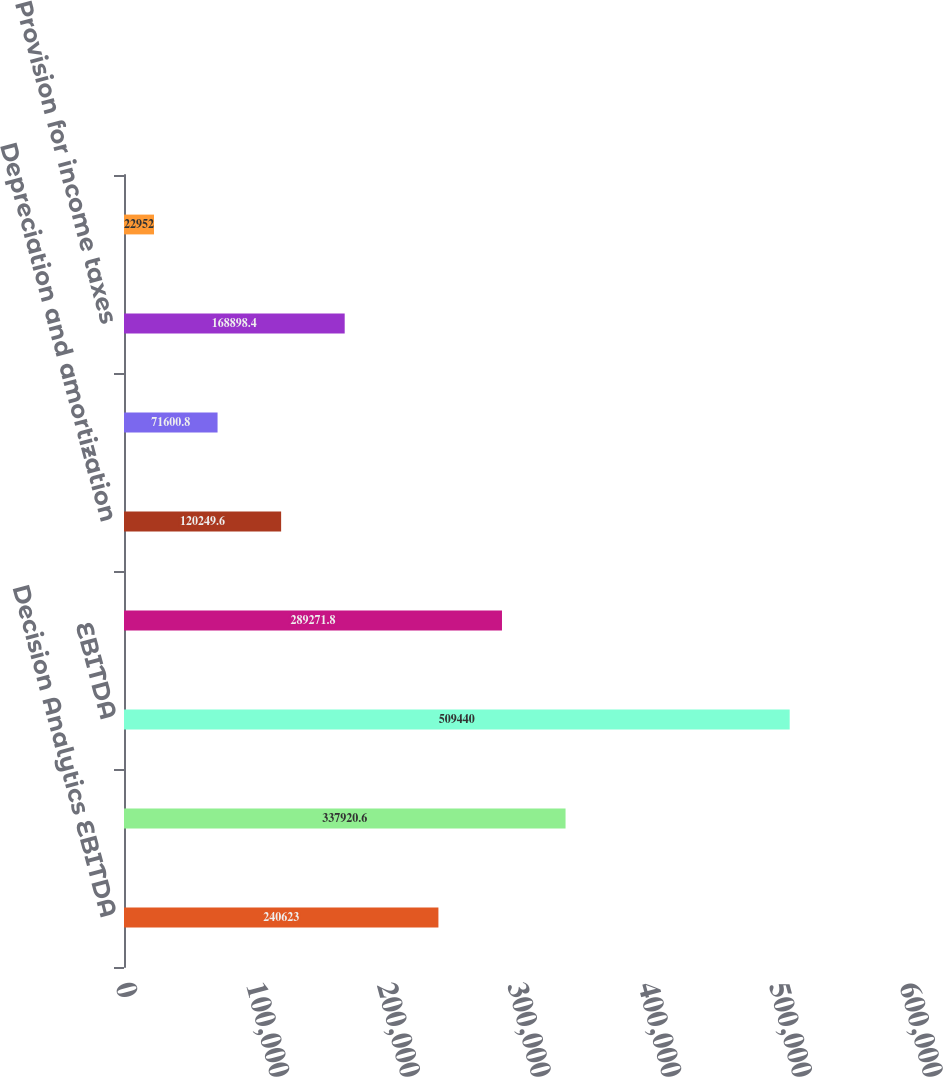Convert chart to OTSL. <chart><loc_0><loc_0><loc_500><loc_500><bar_chart><fcel>Decision Analytics EBITDA<fcel>Risk Assessment EBITDA<fcel>EBITDA<fcel>Net income<fcel>Depreciation and amortization<fcel>Interest expense from<fcel>Provision for income taxes<fcel>Depreciation amortization<nl><fcel>240623<fcel>337921<fcel>509440<fcel>289272<fcel>120250<fcel>71600.8<fcel>168898<fcel>22952<nl></chart> 